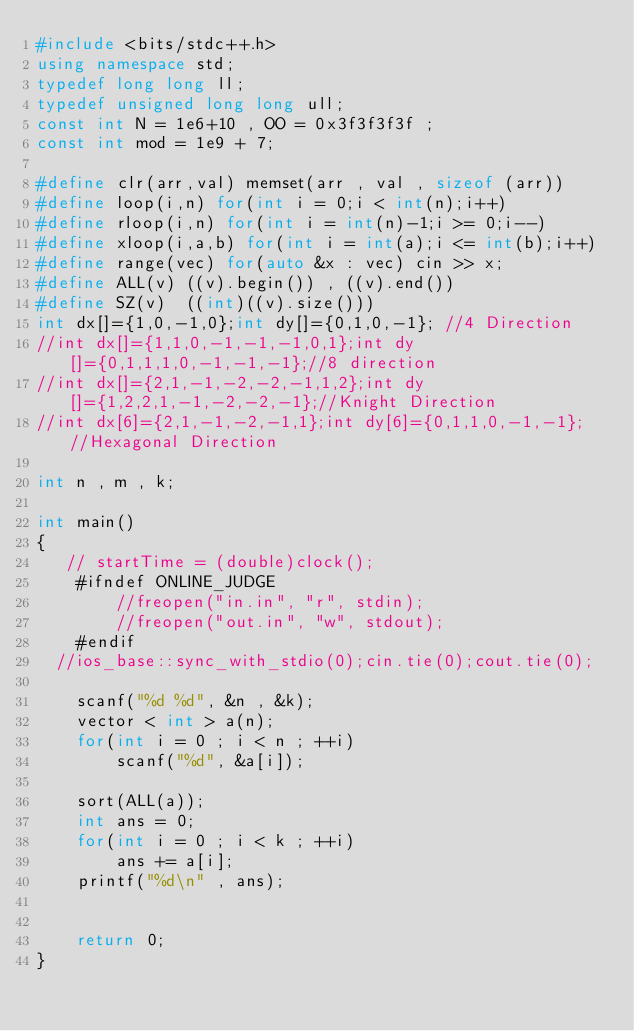Convert code to text. <code><loc_0><loc_0><loc_500><loc_500><_C++_>#include <bits/stdc++.h>
using namespace std;
typedef long long ll;
typedef unsigned long long ull;
const int N = 1e6+10 , OO = 0x3f3f3f3f ;
const int mod = 1e9 + 7;
 
#define clr(arr,val) memset(arr , val , sizeof (arr))
#define loop(i,n) for(int i = 0;i < int(n);i++)
#define rloop(i,n) for(int i = int(n)-1;i >= 0;i--)
#define xloop(i,a,b) for(int i = int(a);i <= int(b);i++)
#define range(vec) for(auto &x : vec) cin >> x;
#define ALL(v) ((v).begin()) , ((v).end())
#define SZ(v)  ((int)((v).size()))
int dx[]={1,0,-1,0};int dy[]={0,1,0,-1}; //4 Direction
//int dx[]={1,1,0,-1,-1,-1,0,1};int dy[]={0,1,1,1,0,-1,-1,-1};//8 direction
//int dx[]={2,1,-1,-2,-2,-1,1,2};int dy[]={1,2,2,1,-1,-2,-2,-1};//Knight Direction
//int dx[6]={2,1,-1,-2,-1,1};int dy[6]={0,1,1,0,-1,-1}; //Hexagonal Direction

int n , m , k;

int main()
{
   // startTime = (double)clock();
    #ifndef ONLINE_JUDGE
        //freopen("in.in", "r", stdin);
        //freopen("out.in", "w", stdout);
    #endif
	//ios_base::sync_with_stdio(0);cin.tie(0);cout.tie(0);
    
    scanf("%d %d", &n , &k);
    vector < int > a(n);
    for(int i = 0 ; i < n ; ++i)
        scanf("%d", &a[i]);
    
    sort(ALL(a));
    int ans = 0;
    for(int i = 0 ; i < k ; ++i)
        ans += a[i];
    printf("%d\n" , ans);


    return 0;
}</code> 